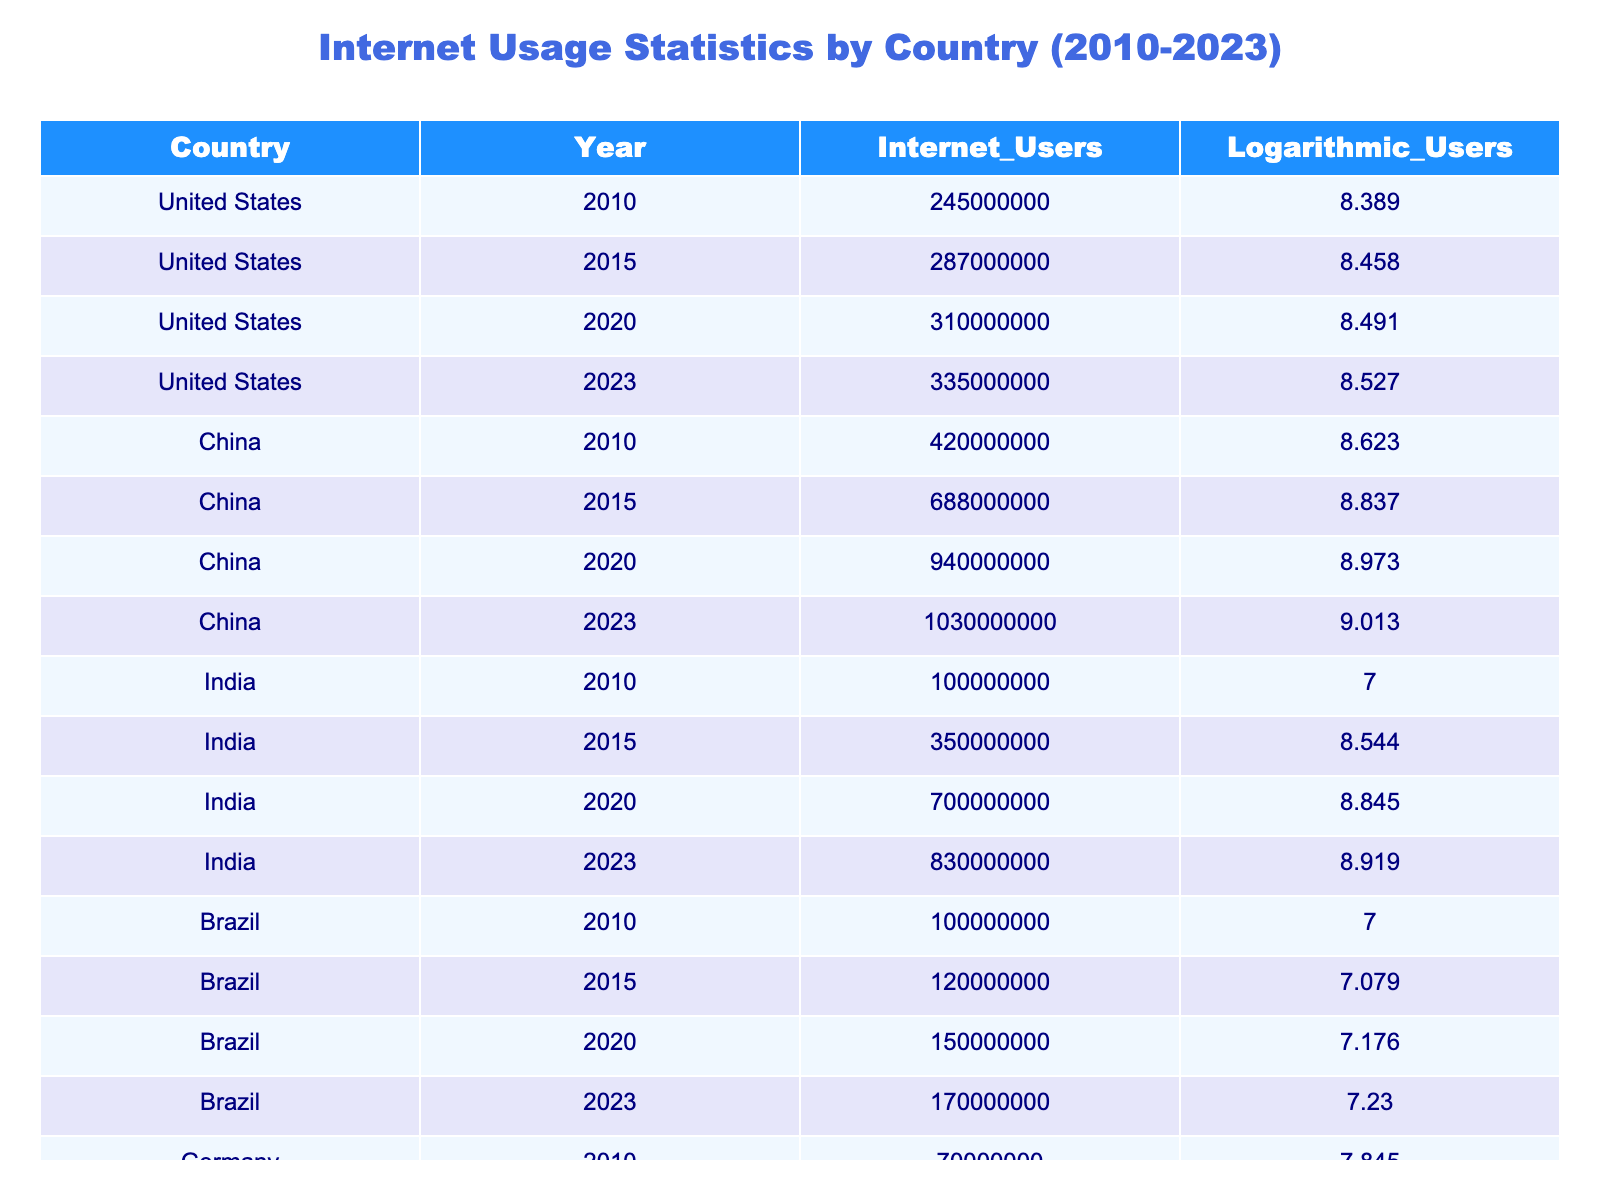What was the number of Internet users in China in 2020? Referring to the table, the number of Internet users in China for the year 2020 is listed directly. It states 940000000.
Answer: 940000000 Which country had the highest logarithmic value of Internet users in 2023? By looking at the logarithmic values for the year 2023, China has the highest value at 9.013 compared to other countries.
Answer: China What is the difference in the number of Internet users in the United States from 2010 to 2023? The number of Internet users in the United States for 2010 is 245000000 and for 2023 is 335000000. To find the difference, subtract the earlier value from the latter: 335000000 - 245000000 = 90000000.
Answer: 90000000 Did Germany have more Internet users in 2023 than in 2010? In 2010, Germany had 70000000 Internet users, and in 2023, it had 90000000. Since 90000000 is greater than 70000000, the statement is true.
Answer: Yes What was the trend in Internet users for India between 2010 and 2023? The Internet users in India increased from 100000000 in 2010 to 830000000 in 2023, indicating a significant upward trend over the years. We can verify this by checking the values for each year listed in the table.
Answer: Increasing trend What is the total number of Internet users in Brazil from 2010 to 2023? To find the total, we need to sum the Internet users across the years: 100000000 (2010) + 120000000 (2015) + 150000000 (2020) + 170000000 (2023) = 540000000.
Answer: 540000000 How many more Internet users did China have compared to the United States in 2020? In 2020, China had 940000000 Internet users, while the United States had 310000000. The difference is 940000000 - 310000000 = 630000000.
Answer: 630000000 What are the logarithmic values for Internet users in Brazil for the years 2010 and 2023? According to the table, Brazil's logarithmic values are 7.000 for 2010 and 7.230 for 2023. We can simply retrieve these values directly from the table.
Answer: 7.000 and 7.230 Is it true that all countries had more Internet users in 2023 than in 2010? To verify, we check the Internet user values for each country: all countries listed show an increase from 2010 to 2023. Therefore, the statement is true.
Answer: Yes 